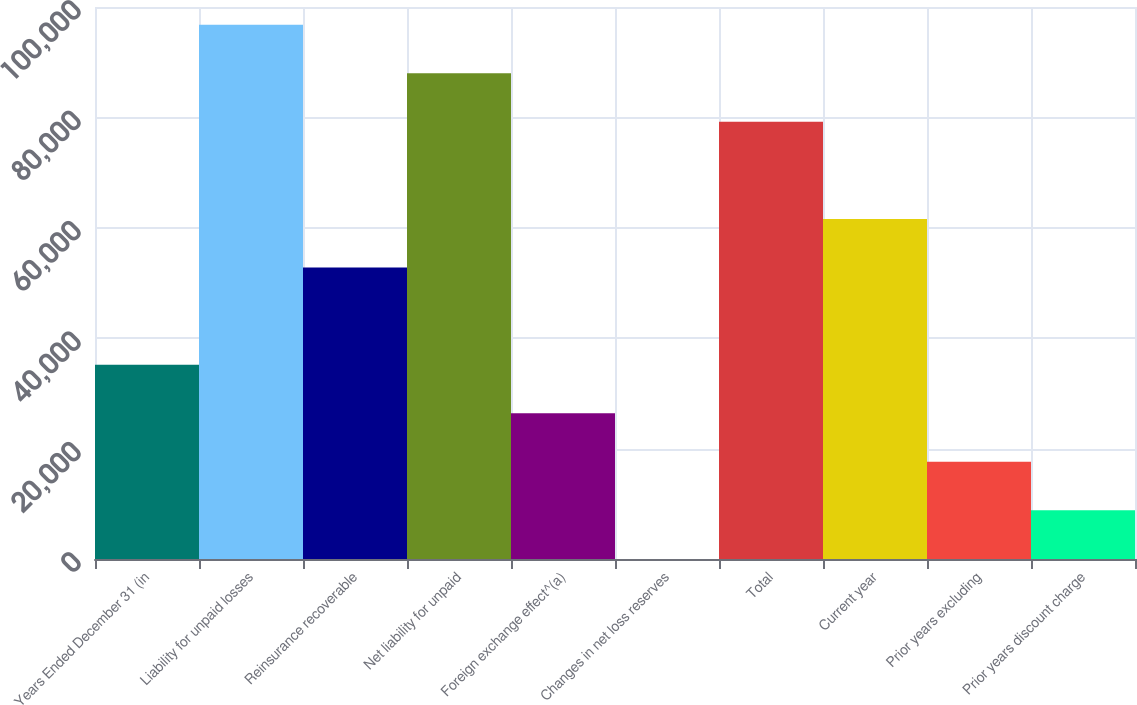Convert chart to OTSL. <chart><loc_0><loc_0><loc_500><loc_500><bar_chart><fcel>Years Ended December 31 (in<fcel>Liability for unpaid losses<fcel>Reinsurance recoverable<fcel>Net liability for unpaid<fcel>Foreign exchange effect^(a)<fcel>Changes in net loss reserves<fcel>Total<fcel>Current year<fcel>Prior years excluding<fcel>Prior years discount charge<nl><fcel>35209.6<fcel>96787.9<fcel>52803.4<fcel>87991<fcel>26412.7<fcel>22<fcel>79194.1<fcel>61600.3<fcel>17615.8<fcel>8818.9<nl></chart> 